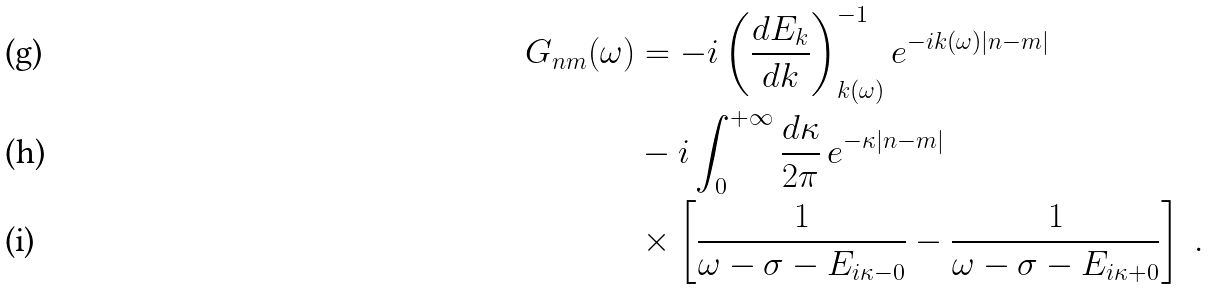Convert formula to latex. <formula><loc_0><loc_0><loc_500><loc_500>G _ { n m } ( \omega ) & = - i \left ( \frac { d E _ { k } } { d k } \right ) ^ { - 1 } _ { k ( \omega ) } e ^ { - i k ( \omega ) | n - m | } \\ & - i \int _ { 0 } ^ { + \infty } \frac { d \kappa } { 2 \pi } \, e ^ { - \kappa | n - m | } \\ & \times \left [ \frac { 1 } { \omega - \sigma - E _ { i \kappa - 0 } } - \frac { 1 } { \omega - \sigma - E _ { i \kappa + 0 } } \right ] \ .</formula> 